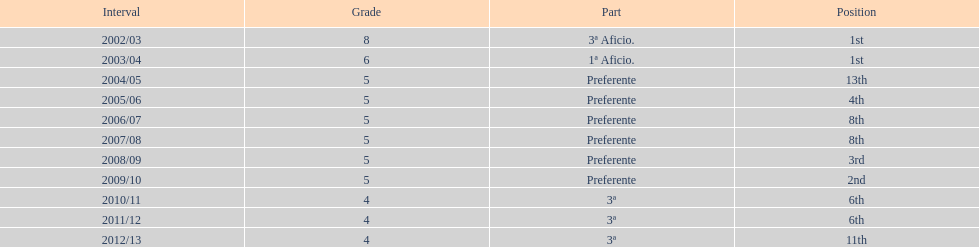What was the number of wins for preferente? 6. 